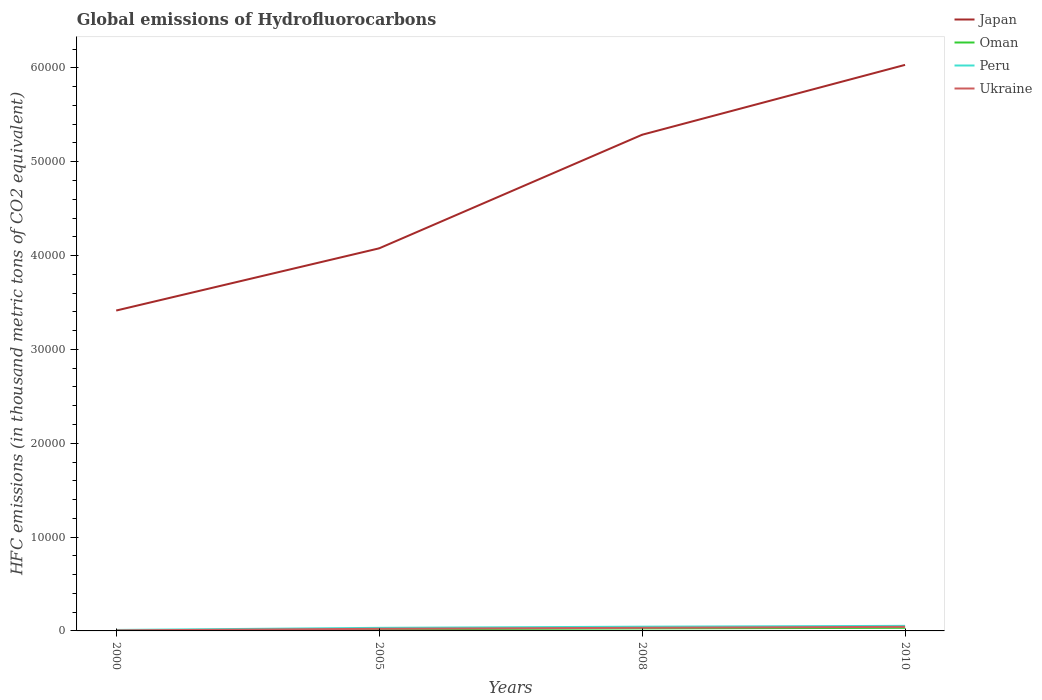How many different coloured lines are there?
Keep it short and to the point. 4. Across all years, what is the maximum global emissions of Hydrofluorocarbons in Ukraine?
Your answer should be very brief. 54.7. In which year was the global emissions of Hydrofluorocarbons in Oman maximum?
Your answer should be very brief. 2000. What is the total global emissions of Hydrofluorocarbons in Peru in the graph?
Make the answer very short. -348.9. What is the difference between the highest and the second highest global emissions of Hydrofluorocarbons in Oman?
Your answer should be compact. 323.4. What is the difference between the highest and the lowest global emissions of Hydrofluorocarbons in Peru?
Your answer should be compact. 2. Is the global emissions of Hydrofluorocarbons in Oman strictly greater than the global emissions of Hydrofluorocarbons in Peru over the years?
Provide a succinct answer. Yes. What is the difference between two consecutive major ticks on the Y-axis?
Offer a terse response. 10000. Are the values on the major ticks of Y-axis written in scientific E-notation?
Keep it short and to the point. No. Does the graph contain any zero values?
Your answer should be very brief. No. How many legend labels are there?
Keep it short and to the point. 4. How are the legend labels stacked?
Your answer should be compact. Vertical. What is the title of the graph?
Make the answer very short. Global emissions of Hydrofluorocarbons. What is the label or title of the X-axis?
Offer a terse response. Years. What is the label or title of the Y-axis?
Offer a terse response. HFC emissions (in thousand metric tons of CO2 equivalent). What is the HFC emissions (in thousand metric tons of CO2 equivalent) of Japan in 2000?
Ensure brevity in your answer.  3.41e+04. What is the HFC emissions (in thousand metric tons of CO2 equivalent) of Oman in 2000?
Provide a short and direct response. 8.6. What is the HFC emissions (in thousand metric tons of CO2 equivalent) of Peru in 2000?
Offer a very short reply. 103.1. What is the HFC emissions (in thousand metric tons of CO2 equivalent) of Ukraine in 2000?
Make the answer very short. 54.7. What is the HFC emissions (in thousand metric tons of CO2 equivalent) in Japan in 2005?
Your answer should be very brief. 4.08e+04. What is the HFC emissions (in thousand metric tons of CO2 equivalent) of Oman in 2005?
Your response must be concise. 173.6. What is the HFC emissions (in thousand metric tons of CO2 equivalent) of Peru in 2005?
Give a very brief answer. 327.6. What is the HFC emissions (in thousand metric tons of CO2 equivalent) of Ukraine in 2005?
Keep it short and to the point. 227.2. What is the HFC emissions (in thousand metric tons of CO2 equivalent) of Japan in 2008?
Give a very brief answer. 5.29e+04. What is the HFC emissions (in thousand metric tons of CO2 equivalent) of Oman in 2008?
Your response must be concise. 266.9. What is the HFC emissions (in thousand metric tons of CO2 equivalent) in Peru in 2008?
Ensure brevity in your answer.  452. What is the HFC emissions (in thousand metric tons of CO2 equivalent) of Ukraine in 2008?
Your response must be concise. 333.5. What is the HFC emissions (in thousand metric tons of CO2 equivalent) of Japan in 2010?
Provide a short and direct response. 6.03e+04. What is the HFC emissions (in thousand metric tons of CO2 equivalent) in Oman in 2010?
Offer a terse response. 332. What is the HFC emissions (in thousand metric tons of CO2 equivalent) in Peru in 2010?
Keep it short and to the point. 539. What is the HFC emissions (in thousand metric tons of CO2 equivalent) in Ukraine in 2010?
Give a very brief answer. 436. Across all years, what is the maximum HFC emissions (in thousand metric tons of CO2 equivalent) of Japan?
Give a very brief answer. 6.03e+04. Across all years, what is the maximum HFC emissions (in thousand metric tons of CO2 equivalent) of Oman?
Provide a succinct answer. 332. Across all years, what is the maximum HFC emissions (in thousand metric tons of CO2 equivalent) of Peru?
Your answer should be compact. 539. Across all years, what is the maximum HFC emissions (in thousand metric tons of CO2 equivalent) in Ukraine?
Your response must be concise. 436. Across all years, what is the minimum HFC emissions (in thousand metric tons of CO2 equivalent) in Japan?
Offer a very short reply. 3.41e+04. Across all years, what is the minimum HFC emissions (in thousand metric tons of CO2 equivalent) of Peru?
Your response must be concise. 103.1. Across all years, what is the minimum HFC emissions (in thousand metric tons of CO2 equivalent) in Ukraine?
Your answer should be compact. 54.7. What is the total HFC emissions (in thousand metric tons of CO2 equivalent) in Japan in the graph?
Your answer should be very brief. 1.88e+05. What is the total HFC emissions (in thousand metric tons of CO2 equivalent) in Oman in the graph?
Provide a succinct answer. 781.1. What is the total HFC emissions (in thousand metric tons of CO2 equivalent) of Peru in the graph?
Offer a very short reply. 1421.7. What is the total HFC emissions (in thousand metric tons of CO2 equivalent) in Ukraine in the graph?
Your answer should be very brief. 1051.4. What is the difference between the HFC emissions (in thousand metric tons of CO2 equivalent) of Japan in 2000 and that in 2005?
Give a very brief answer. -6628.7. What is the difference between the HFC emissions (in thousand metric tons of CO2 equivalent) of Oman in 2000 and that in 2005?
Your answer should be compact. -165. What is the difference between the HFC emissions (in thousand metric tons of CO2 equivalent) in Peru in 2000 and that in 2005?
Make the answer very short. -224.5. What is the difference between the HFC emissions (in thousand metric tons of CO2 equivalent) in Ukraine in 2000 and that in 2005?
Offer a very short reply. -172.5. What is the difference between the HFC emissions (in thousand metric tons of CO2 equivalent) of Japan in 2000 and that in 2008?
Your answer should be compact. -1.87e+04. What is the difference between the HFC emissions (in thousand metric tons of CO2 equivalent) of Oman in 2000 and that in 2008?
Offer a very short reply. -258.3. What is the difference between the HFC emissions (in thousand metric tons of CO2 equivalent) in Peru in 2000 and that in 2008?
Your response must be concise. -348.9. What is the difference between the HFC emissions (in thousand metric tons of CO2 equivalent) in Ukraine in 2000 and that in 2008?
Provide a short and direct response. -278.8. What is the difference between the HFC emissions (in thousand metric tons of CO2 equivalent) of Japan in 2000 and that in 2010?
Your response must be concise. -2.62e+04. What is the difference between the HFC emissions (in thousand metric tons of CO2 equivalent) in Oman in 2000 and that in 2010?
Make the answer very short. -323.4. What is the difference between the HFC emissions (in thousand metric tons of CO2 equivalent) in Peru in 2000 and that in 2010?
Your answer should be compact. -435.9. What is the difference between the HFC emissions (in thousand metric tons of CO2 equivalent) of Ukraine in 2000 and that in 2010?
Offer a terse response. -381.3. What is the difference between the HFC emissions (in thousand metric tons of CO2 equivalent) of Japan in 2005 and that in 2008?
Make the answer very short. -1.21e+04. What is the difference between the HFC emissions (in thousand metric tons of CO2 equivalent) of Oman in 2005 and that in 2008?
Ensure brevity in your answer.  -93.3. What is the difference between the HFC emissions (in thousand metric tons of CO2 equivalent) of Peru in 2005 and that in 2008?
Your answer should be compact. -124.4. What is the difference between the HFC emissions (in thousand metric tons of CO2 equivalent) of Ukraine in 2005 and that in 2008?
Your answer should be compact. -106.3. What is the difference between the HFC emissions (in thousand metric tons of CO2 equivalent) of Japan in 2005 and that in 2010?
Your response must be concise. -1.95e+04. What is the difference between the HFC emissions (in thousand metric tons of CO2 equivalent) of Oman in 2005 and that in 2010?
Your answer should be compact. -158.4. What is the difference between the HFC emissions (in thousand metric tons of CO2 equivalent) in Peru in 2005 and that in 2010?
Provide a short and direct response. -211.4. What is the difference between the HFC emissions (in thousand metric tons of CO2 equivalent) of Ukraine in 2005 and that in 2010?
Offer a very short reply. -208.8. What is the difference between the HFC emissions (in thousand metric tons of CO2 equivalent) in Japan in 2008 and that in 2010?
Your answer should be very brief. -7446.1. What is the difference between the HFC emissions (in thousand metric tons of CO2 equivalent) of Oman in 2008 and that in 2010?
Provide a short and direct response. -65.1. What is the difference between the HFC emissions (in thousand metric tons of CO2 equivalent) in Peru in 2008 and that in 2010?
Your answer should be very brief. -87. What is the difference between the HFC emissions (in thousand metric tons of CO2 equivalent) in Ukraine in 2008 and that in 2010?
Your answer should be very brief. -102.5. What is the difference between the HFC emissions (in thousand metric tons of CO2 equivalent) of Japan in 2000 and the HFC emissions (in thousand metric tons of CO2 equivalent) of Oman in 2005?
Ensure brevity in your answer.  3.40e+04. What is the difference between the HFC emissions (in thousand metric tons of CO2 equivalent) of Japan in 2000 and the HFC emissions (in thousand metric tons of CO2 equivalent) of Peru in 2005?
Provide a succinct answer. 3.38e+04. What is the difference between the HFC emissions (in thousand metric tons of CO2 equivalent) of Japan in 2000 and the HFC emissions (in thousand metric tons of CO2 equivalent) of Ukraine in 2005?
Your answer should be very brief. 3.39e+04. What is the difference between the HFC emissions (in thousand metric tons of CO2 equivalent) of Oman in 2000 and the HFC emissions (in thousand metric tons of CO2 equivalent) of Peru in 2005?
Keep it short and to the point. -319. What is the difference between the HFC emissions (in thousand metric tons of CO2 equivalent) in Oman in 2000 and the HFC emissions (in thousand metric tons of CO2 equivalent) in Ukraine in 2005?
Make the answer very short. -218.6. What is the difference between the HFC emissions (in thousand metric tons of CO2 equivalent) of Peru in 2000 and the HFC emissions (in thousand metric tons of CO2 equivalent) of Ukraine in 2005?
Your answer should be compact. -124.1. What is the difference between the HFC emissions (in thousand metric tons of CO2 equivalent) of Japan in 2000 and the HFC emissions (in thousand metric tons of CO2 equivalent) of Oman in 2008?
Offer a terse response. 3.39e+04. What is the difference between the HFC emissions (in thousand metric tons of CO2 equivalent) of Japan in 2000 and the HFC emissions (in thousand metric tons of CO2 equivalent) of Peru in 2008?
Your response must be concise. 3.37e+04. What is the difference between the HFC emissions (in thousand metric tons of CO2 equivalent) of Japan in 2000 and the HFC emissions (in thousand metric tons of CO2 equivalent) of Ukraine in 2008?
Make the answer very short. 3.38e+04. What is the difference between the HFC emissions (in thousand metric tons of CO2 equivalent) in Oman in 2000 and the HFC emissions (in thousand metric tons of CO2 equivalent) in Peru in 2008?
Offer a terse response. -443.4. What is the difference between the HFC emissions (in thousand metric tons of CO2 equivalent) of Oman in 2000 and the HFC emissions (in thousand metric tons of CO2 equivalent) of Ukraine in 2008?
Give a very brief answer. -324.9. What is the difference between the HFC emissions (in thousand metric tons of CO2 equivalent) of Peru in 2000 and the HFC emissions (in thousand metric tons of CO2 equivalent) of Ukraine in 2008?
Ensure brevity in your answer.  -230.4. What is the difference between the HFC emissions (in thousand metric tons of CO2 equivalent) in Japan in 2000 and the HFC emissions (in thousand metric tons of CO2 equivalent) in Oman in 2010?
Make the answer very short. 3.38e+04. What is the difference between the HFC emissions (in thousand metric tons of CO2 equivalent) of Japan in 2000 and the HFC emissions (in thousand metric tons of CO2 equivalent) of Peru in 2010?
Offer a terse response. 3.36e+04. What is the difference between the HFC emissions (in thousand metric tons of CO2 equivalent) of Japan in 2000 and the HFC emissions (in thousand metric tons of CO2 equivalent) of Ukraine in 2010?
Give a very brief answer. 3.37e+04. What is the difference between the HFC emissions (in thousand metric tons of CO2 equivalent) of Oman in 2000 and the HFC emissions (in thousand metric tons of CO2 equivalent) of Peru in 2010?
Your response must be concise. -530.4. What is the difference between the HFC emissions (in thousand metric tons of CO2 equivalent) in Oman in 2000 and the HFC emissions (in thousand metric tons of CO2 equivalent) in Ukraine in 2010?
Your answer should be compact. -427.4. What is the difference between the HFC emissions (in thousand metric tons of CO2 equivalent) in Peru in 2000 and the HFC emissions (in thousand metric tons of CO2 equivalent) in Ukraine in 2010?
Your response must be concise. -332.9. What is the difference between the HFC emissions (in thousand metric tons of CO2 equivalent) in Japan in 2005 and the HFC emissions (in thousand metric tons of CO2 equivalent) in Oman in 2008?
Offer a terse response. 4.05e+04. What is the difference between the HFC emissions (in thousand metric tons of CO2 equivalent) in Japan in 2005 and the HFC emissions (in thousand metric tons of CO2 equivalent) in Peru in 2008?
Keep it short and to the point. 4.03e+04. What is the difference between the HFC emissions (in thousand metric tons of CO2 equivalent) of Japan in 2005 and the HFC emissions (in thousand metric tons of CO2 equivalent) of Ukraine in 2008?
Your answer should be compact. 4.04e+04. What is the difference between the HFC emissions (in thousand metric tons of CO2 equivalent) in Oman in 2005 and the HFC emissions (in thousand metric tons of CO2 equivalent) in Peru in 2008?
Ensure brevity in your answer.  -278.4. What is the difference between the HFC emissions (in thousand metric tons of CO2 equivalent) of Oman in 2005 and the HFC emissions (in thousand metric tons of CO2 equivalent) of Ukraine in 2008?
Provide a succinct answer. -159.9. What is the difference between the HFC emissions (in thousand metric tons of CO2 equivalent) of Peru in 2005 and the HFC emissions (in thousand metric tons of CO2 equivalent) of Ukraine in 2008?
Offer a very short reply. -5.9. What is the difference between the HFC emissions (in thousand metric tons of CO2 equivalent) of Japan in 2005 and the HFC emissions (in thousand metric tons of CO2 equivalent) of Oman in 2010?
Make the answer very short. 4.04e+04. What is the difference between the HFC emissions (in thousand metric tons of CO2 equivalent) in Japan in 2005 and the HFC emissions (in thousand metric tons of CO2 equivalent) in Peru in 2010?
Offer a terse response. 4.02e+04. What is the difference between the HFC emissions (in thousand metric tons of CO2 equivalent) in Japan in 2005 and the HFC emissions (in thousand metric tons of CO2 equivalent) in Ukraine in 2010?
Give a very brief answer. 4.03e+04. What is the difference between the HFC emissions (in thousand metric tons of CO2 equivalent) in Oman in 2005 and the HFC emissions (in thousand metric tons of CO2 equivalent) in Peru in 2010?
Provide a succinct answer. -365.4. What is the difference between the HFC emissions (in thousand metric tons of CO2 equivalent) of Oman in 2005 and the HFC emissions (in thousand metric tons of CO2 equivalent) of Ukraine in 2010?
Your answer should be very brief. -262.4. What is the difference between the HFC emissions (in thousand metric tons of CO2 equivalent) of Peru in 2005 and the HFC emissions (in thousand metric tons of CO2 equivalent) of Ukraine in 2010?
Offer a terse response. -108.4. What is the difference between the HFC emissions (in thousand metric tons of CO2 equivalent) in Japan in 2008 and the HFC emissions (in thousand metric tons of CO2 equivalent) in Oman in 2010?
Your answer should be very brief. 5.25e+04. What is the difference between the HFC emissions (in thousand metric tons of CO2 equivalent) of Japan in 2008 and the HFC emissions (in thousand metric tons of CO2 equivalent) of Peru in 2010?
Offer a very short reply. 5.23e+04. What is the difference between the HFC emissions (in thousand metric tons of CO2 equivalent) of Japan in 2008 and the HFC emissions (in thousand metric tons of CO2 equivalent) of Ukraine in 2010?
Your answer should be very brief. 5.24e+04. What is the difference between the HFC emissions (in thousand metric tons of CO2 equivalent) of Oman in 2008 and the HFC emissions (in thousand metric tons of CO2 equivalent) of Peru in 2010?
Give a very brief answer. -272.1. What is the difference between the HFC emissions (in thousand metric tons of CO2 equivalent) in Oman in 2008 and the HFC emissions (in thousand metric tons of CO2 equivalent) in Ukraine in 2010?
Provide a short and direct response. -169.1. What is the average HFC emissions (in thousand metric tons of CO2 equivalent) in Japan per year?
Your answer should be compact. 4.70e+04. What is the average HFC emissions (in thousand metric tons of CO2 equivalent) of Oman per year?
Provide a succinct answer. 195.28. What is the average HFC emissions (in thousand metric tons of CO2 equivalent) in Peru per year?
Make the answer very short. 355.43. What is the average HFC emissions (in thousand metric tons of CO2 equivalent) of Ukraine per year?
Your answer should be compact. 262.85. In the year 2000, what is the difference between the HFC emissions (in thousand metric tons of CO2 equivalent) in Japan and HFC emissions (in thousand metric tons of CO2 equivalent) in Oman?
Offer a very short reply. 3.41e+04. In the year 2000, what is the difference between the HFC emissions (in thousand metric tons of CO2 equivalent) of Japan and HFC emissions (in thousand metric tons of CO2 equivalent) of Peru?
Your answer should be compact. 3.40e+04. In the year 2000, what is the difference between the HFC emissions (in thousand metric tons of CO2 equivalent) in Japan and HFC emissions (in thousand metric tons of CO2 equivalent) in Ukraine?
Your response must be concise. 3.41e+04. In the year 2000, what is the difference between the HFC emissions (in thousand metric tons of CO2 equivalent) of Oman and HFC emissions (in thousand metric tons of CO2 equivalent) of Peru?
Provide a succinct answer. -94.5. In the year 2000, what is the difference between the HFC emissions (in thousand metric tons of CO2 equivalent) of Oman and HFC emissions (in thousand metric tons of CO2 equivalent) of Ukraine?
Ensure brevity in your answer.  -46.1. In the year 2000, what is the difference between the HFC emissions (in thousand metric tons of CO2 equivalent) in Peru and HFC emissions (in thousand metric tons of CO2 equivalent) in Ukraine?
Offer a terse response. 48.4. In the year 2005, what is the difference between the HFC emissions (in thousand metric tons of CO2 equivalent) in Japan and HFC emissions (in thousand metric tons of CO2 equivalent) in Oman?
Keep it short and to the point. 4.06e+04. In the year 2005, what is the difference between the HFC emissions (in thousand metric tons of CO2 equivalent) of Japan and HFC emissions (in thousand metric tons of CO2 equivalent) of Peru?
Your response must be concise. 4.04e+04. In the year 2005, what is the difference between the HFC emissions (in thousand metric tons of CO2 equivalent) of Japan and HFC emissions (in thousand metric tons of CO2 equivalent) of Ukraine?
Offer a very short reply. 4.05e+04. In the year 2005, what is the difference between the HFC emissions (in thousand metric tons of CO2 equivalent) in Oman and HFC emissions (in thousand metric tons of CO2 equivalent) in Peru?
Give a very brief answer. -154. In the year 2005, what is the difference between the HFC emissions (in thousand metric tons of CO2 equivalent) in Oman and HFC emissions (in thousand metric tons of CO2 equivalent) in Ukraine?
Make the answer very short. -53.6. In the year 2005, what is the difference between the HFC emissions (in thousand metric tons of CO2 equivalent) in Peru and HFC emissions (in thousand metric tons of CO2 equivalent) in Ukraine?
Provide a succinct answer. 100.4. In the year 2008, what is the difference between the HFC emissions (in thousand metric tons of CO2 equivalent) of Japan and HFC emissions (in thousand metric tons of CO2 equivalent) of Oman?
Provide a short and direct response. 5.26e+04. In the year 2008, what is the difference between the HFC emissions (in thousand metric tons of CO2 equivalent) of Japan and HFC emissions (in thousand metric tons of CO2 equivalent) of Peru?
Offer a terse response. 5.24e+04. In the year 2008, what is the difference between the HFC emissions (in thousand metric tons of CO2 equivalent) of Japan and HFC emissions (in thousand metric tons of CO2 equivalent) of Ukraine?
Ensure brevity in your answer.  5.25e+04. In the year 2008, what is the difference between the HFC emissions (in thousand metric tons of CO2 equivalent) of Oman and HFC emissions (in thousand metric tons of CO2 equivalent) of Peru?
Keep it short and to the point. -185.1. In the year 2008, what is the difference between the HFC emissions (in thousand metric tons of CO2 equivalent) in Oman and HFC emissions (in thousand metric tons of CO2 equivalent) in Ukraine?
Keep it short and to the point. -66.6. In the year 2008, what is the difference between the HFC emissions (in thousand metric tons of CO2 equivalent) of Peru and HFC emissions (in thousand metric tons of CO2 equivalent) of Ukraine?
Offer a terse response. 118.5. In the year 2010, what is the difference between the HFC emissions (in thousand metric tons of CO2 equivalent) in Japan and HFC emissions (in thousand metric tons of CO2 equivalent) in Oman?
Keep it short and to the point. 6.00e+04. In the year 2010, what is the difference between the HFC emissions (in thousand metric tons of CO2 equivalent) in Japan and HFC emissions (in thousand metric tons of CO2 equivalent) in Peru?
Offer a terse response. 5.98e+04. In the year 2010, what is the difference between the HFC emissions (in thousand metric tons of CO2 equivalent) of Japan and HFC emissions (in thousand metric tons of CO2 equivalent) of Ukraine?
Your answer should be compact. 5.99e+04. In the year 2010, what is the difference between the HFC emissions (in thousand metric tons of CO2 equivalent) of Oman and HFC emissions (in thousand metric tons of CO2 equivalent) of Peru?
Your answer should be very brief. -207. In the year 2010, what is the difference between the HFC emissions (in thousand metric tons of CO2 equivalent) in Oman and HFC emissions (in thousand metric tons of CO2 equivalent) in Ukraine?
Provide a short and direct response. -104. In the year 2010, what is the difference between the HFC emissions (in thousand metric tons of CO2 equivalent) in Peru and HFC emissions (in thousand metric tons of CO2 equivalent) in Ukraine?
Ensure brevity in your answer.  103. What is the ratio of the HFC emissions (in thousand metric tons of CO2 equivalent) of Japan in 2000 to that in 2005?
Keep it short and to the point. 0.84. What is the ratio of the HFC emissions (in thousand metric tons of CO2 equivalent) in Oman in 2000 to that in 2005?
Offer a very short reply. 0.05. What is the ratio of the HFC emissions (in thousand metric tons of CO2 equivalent) of Peru in 2000 to that in 2005?
Give a very brief answer. 0.31. What is the ratio of the HFC emissions (in thousand metric tons of CO2 equivalent) in Ukraine in 2000 to that in 2005?
Give a very brief answer. 0.24. What is the ratio of the HFC emissions (in thousand metric tons of CO2 equivalent) in Japan in 2000 to that in 2008?
Make the answer very short. 0.65. What is the ratio of the HFC emissions (in thousand metric tons of CO2 equivalent) in Oman in 2000 to that in 2008?
Offer a very short reply. 0.03. What is the ratio of the HFC emissions (in thousand metric tons of CO2 equivalent) of Peru in 2000 to that in 2008?
Make the answer very short. 0.23. What is the ratio of the HFC emissions (in thousand metric tons of CO2 equivalent) in Ukraine in 2000 to that in 2008?
Ensure brevity in your answer.  0.16. What is the ratio of the HFC emissions (in thousand metric tons of CO2 equivalent) in Japan in 2000 to that in 2010?
Give a very brief answer. 0.57. What is the ratio of the HFC emissions (in thousand metric tons of CO2 equivalent) in Oman in 2000 to that in 2010?
Your response must be concise. 0.03. What is the ratio of the HFC emissions (in thousand metric tons of CO2 equivalent) in Peru in 2000 to that in 2010?
Offer a terse response. 0.19. What is the ratio of the HFC emissions (in thousand metric tons of CO2 equivalent) of Ukraine in 2000 to that in 2010?
Your response must be concise. 0.13. What is the ratio of the HFC emissions (in thousand metric tons of CO2 equivalent) of Japan in 2005 to that in 2008?
Offer a terse response. 0.77. What is the ratio of the HFC emissions (in thousand metric tons of CO2 equivalent) in Oman in 2005 to that in 2008?
Offer a very short reply. 0.65. What is the ratio of the HFC emissions (in thousand metric tons of CO2 equivalent) in Peru in 2005 to that in 2008?
Provide a short and direct response. 0.72. What is the ratio of the HFC emissions (in thousand metric tons of CO2 equivalent) in Ukraine in 2005 to that in 2008?
Your response must be concise. 0.68. What is the ratio of the HFC emissions (in thousand metric tons of CO2 equivalent) of Japan in 2005 to that in 2010?
Provide a succinct answer. 0.68. What is the ratio of the HFC emissions (in thousand metric tons of CO2 equivalent) in Oman in 2005 to that in 2010?
Provide a succinct answer. 0.52. What is the ratio of the HFC emissions (in thousand metric tons of CO2 equivalent) of Peru in 2005 to that in 2010?
Provide a succinct answer. 0.61. What is the ratio of the HFC emissions (in thousand metric tons of CO2 equivalent) of Ukraine in 2005 to that in 2010?
Your answer should be compact. 0.52. What is the ratio of the HFC emissions (in thousand metric tons of CO2 equivalent) of Japan in 2008 to that in 2010?
Your answer should be compact. 0.88. What is the ratio of the HFC emissions (in thousand metric tons of CO2 equivalent) in Oman in 2008 to that in 2010?
Make the answer very short. 0.8. What is the ratio of the HFC emissions (in thousand metric tons of CO2 equivalent) in Peru in 2008 to that in 2010?
Give a very brief answer. 0.84. What is the ratio of the HFC emissions (in thousand metric tons of CO2 equivalent) in Ukraine in 2008 to that in 2010?
Your answer should be compact. 0.76. What is the difference between the highest and the second highest HFC emissions (in thousand metric tons of CO2 equivalent) in Japan?
Make the answer very short. 7446.1. What is the difference between the highest and the second highest HFC emissions (in thousand metric tons of CO2 equivalent) in Oman?
Keep it short and to the point. 65.1. What is the difference between the highest and the second highest HFC emissions (in thousand metric tons of CO2 equivalent) of Peru?
Ensure brevity in your answer.  87. What is the difference between the highest and the second highest HFC emissions (in thousand metric tons of CO2 equivalent) of Ukraine?
Offer a terse response. 102.5. What is the difference between the highest and the lowest HFC emissions (in thousand metric tons of CO2 equivalent) in Japan?
Make the answer very short. 2.62e+04. What is the difference between the highest and the lowest HFC emissions (in thousand metric tons of CO2 equivalent) of Oman?
Keep it short and to the point. 323.4. What is the difference between the highest and the lowest HFC emissions (in thousand metric tons of CO2 equivalent) in Peru?
Ensure brevity in your answer.  435.9. What is the difference between the highest and the lowest HFC emissions (in thousand metric tons of CO2 equivalent) of Ukraine?
Provide a short and direct response. 381.3. 